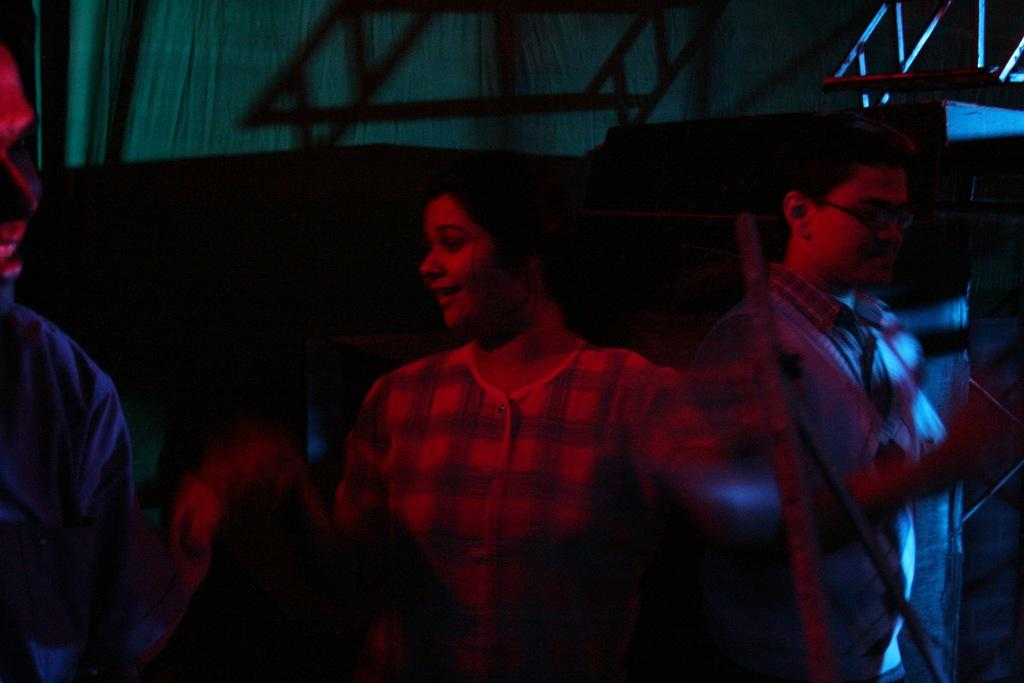How many people are in the image? There are three persons standing in the image. What is the surface they are standing on? The persons are standing on the floor. What type of window treatment can be seen in the image? There are curtains visible in the image. What else can be seen in the background of the image? There are other objects present in the background of the image. What type of volleyball is being played in the image? There is no volleyball or any indication of a game being played in the image. Does the existence of the persons in the image prove the existence of extraterrestrial life? The presence of the persons in the image does not prove the existence of extraterrestrial life, as they appear to be human. 